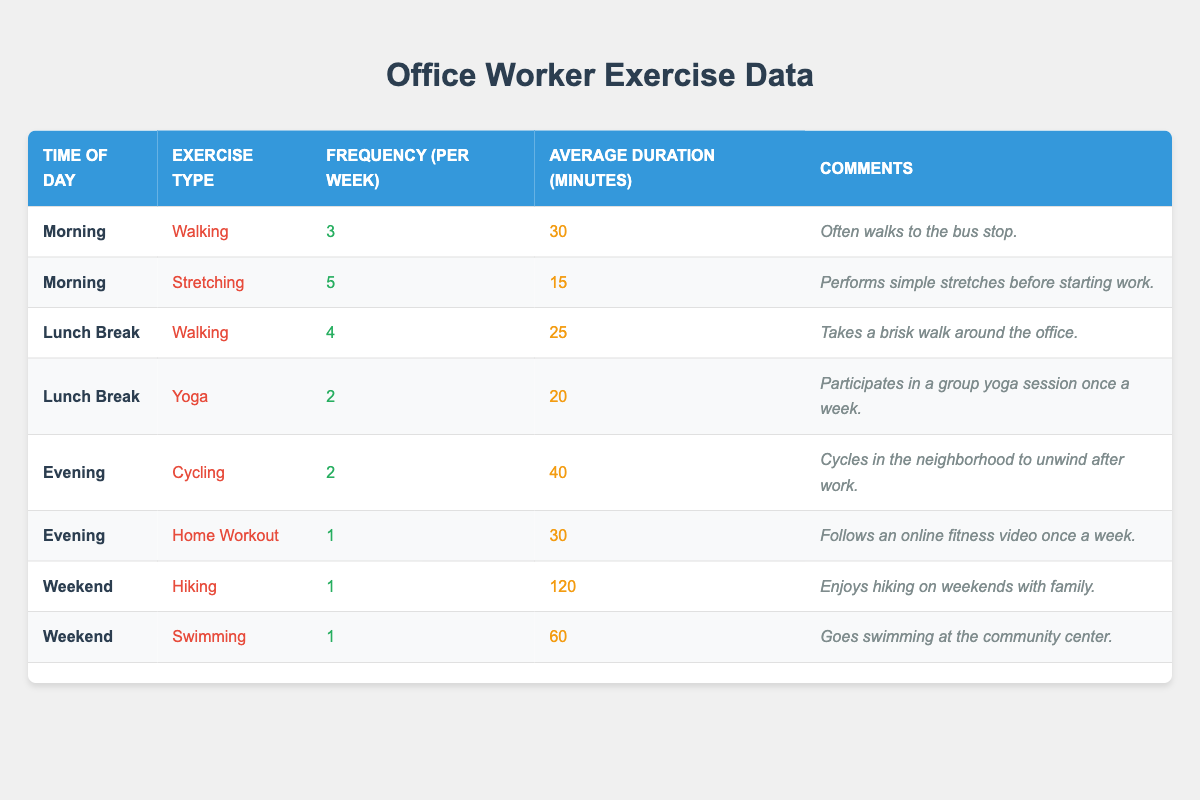What exercise type has the highest frequency in the morning? The table lists the exercises done in the morning along with their frequency. Stretching is done 5 times per week, which is more frequent than walking, which is done 3 times.
Answer: Stretching How many minutes do office workers spend on average walking during their lunch break? The table shows that walking during lunch breaks has an average duration of 25 minutes, which directly provides the answer without needing further calculations.
Answer: 25 minutes Is there any exercise type done more than once a week in the evening? By reviewing the evening exercises, cycling is done 2 times a week, while home workout is done only once a week. Therefore, yes, cycling is the exercise type done more than once a week in the evening.
Answer: Yes What is the total frequency of all exercises performed during lunch breaks? The lunch break exercises are walking (4 times) and yoga (2 times). Adding these frequencies together gives 4 + 2 = 6, which represents the total frequency of all lunch break exercises.
Answer: 6 During which time of day do office workers have the longest average duration of exercise? The table indicates that during the weekend, hiking has the longest average duration of 120 minutes. This is higher than any other time of day for any exercise type listed.
Answer: Weekend Which exercise type has the least frequency and how often is it performed? The table shows that home workout, hiking, and swimming each has a frequency of 1 time per week. Therefore, any of these could be considered the least frequent; choosing home workout: it is performed once a week.
Answer: Home workout, 1 time What is the average duration of exercises during the weekend? The average duration includes hiking (120 minutes) and swimming (60 minutes). To find the average: (120 + 60) / 2 = 90 minutes, meaning that on average, weekend exercises take this much time.
Answer: 90 minutes Is it true that yoga has a longer average duration than walking during lunch breaks? Yoga has an average duration of 20 minutes while walking has 25 minutes. Thus, it is false that yoga has a longer average duration than walking.
Answer: No What is the total duration spent on stretching and walking in the morning? Stretching has an average duration of 15 minutes and walking 30 minutes. Adding these gives 15 + 30 = 45 minutes total duration spent on both exercises in the morning.
Answer: 45 minutes Which exercise is performed only once a week during the evening? The table lists home workout as the only exercise performed once a week in the evening, while cycling is performed twice a week, meaning this is the only qualifying exercise.
Answer: Home workout 